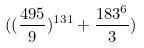Convert formula to latex. <formula><loc_0><loc_0><loc_500><loc_500>( ( \frac { 4 9 5 } { 9 } ) ^ { 1 3 1 } + \frac { 1 8 3 ^ { 6 } } { 3 } )</formula> 